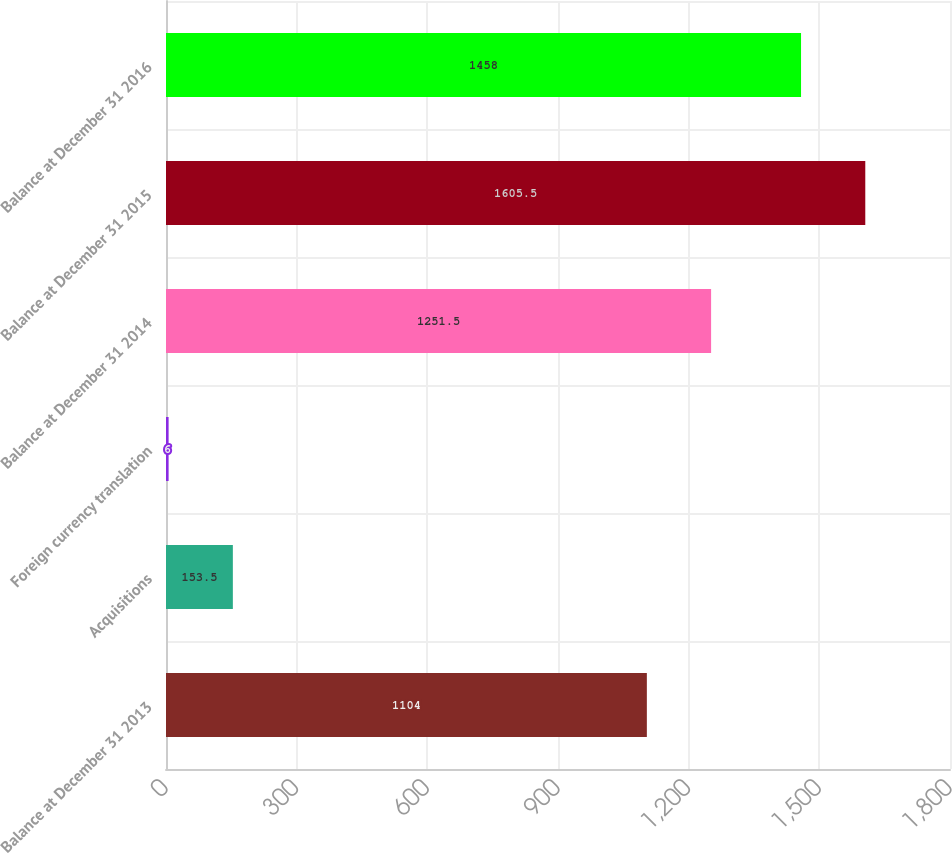Convert chart. <chart><loc_0><loc_0><loc_500><loc_500><bar_chart><fcel>Balance at December 31 2013<fcel>Acquisitions<fcel>Foreign currency translation<fcel>Balance at December 31 2014<fcel>Balance at December 31 2015<fcel>Balance at December 31 2016<nl><fcel>1104<fcel>153.5<fcel>6<fcel>1251.5<fcel>1605.5<fcel>1458<nl></chart> 